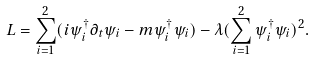Convert formula to latex. <formula><loc_0><loc_0><loc_500><loc_500>L = \sum _ { i = 1 } ^ { 2 } ( i \psi _ { i } ^ { \dag } \partial _ { t } \psi _ { i } - m \psi _ { i } ^ { \dag } \psi _ { i } ) - \lambda ( \sum _ { i = 1 } ^ { 2 } \psi _ { i } ^ { \dag } \psi _ { i } ) ^ { 2 } .</formula> 